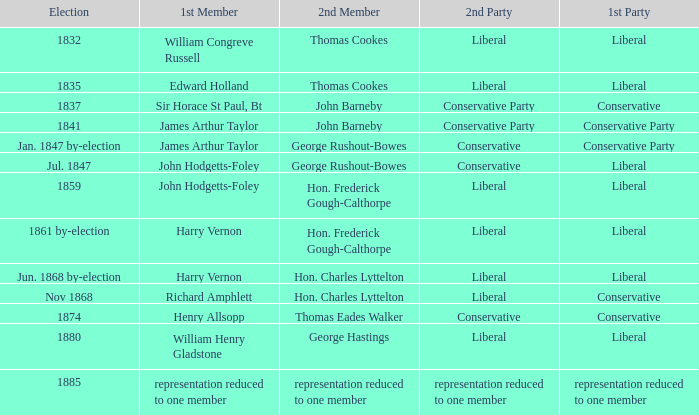What was the other party when its next member was george rushout-bowes, and the primary party was liberal? Conservative. 